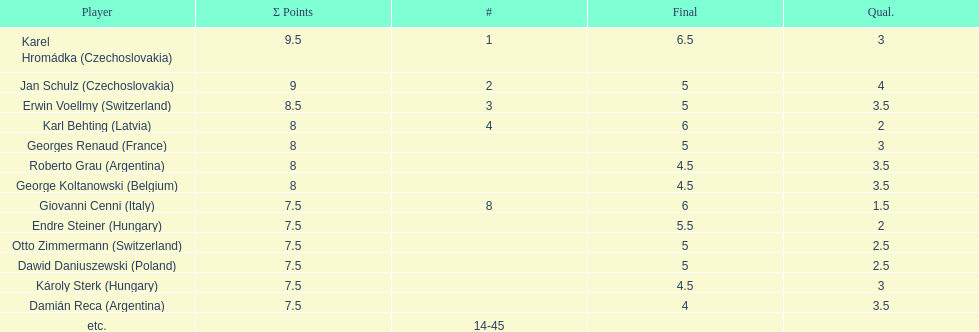How many players had a 8 points? 4. 